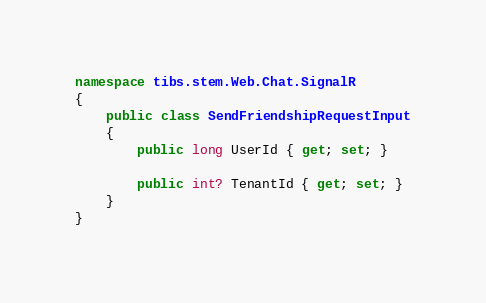<code> <loc_0><loc_0><loc_500><loc_500><_C#_>namespace tibs.stem.Web.Chat.SignalR
{
    public class SendFriendshipRequestInput
    {
        public long UserId { get; set; }

        public int? TenantId { get; set; }
    }
}</code> 